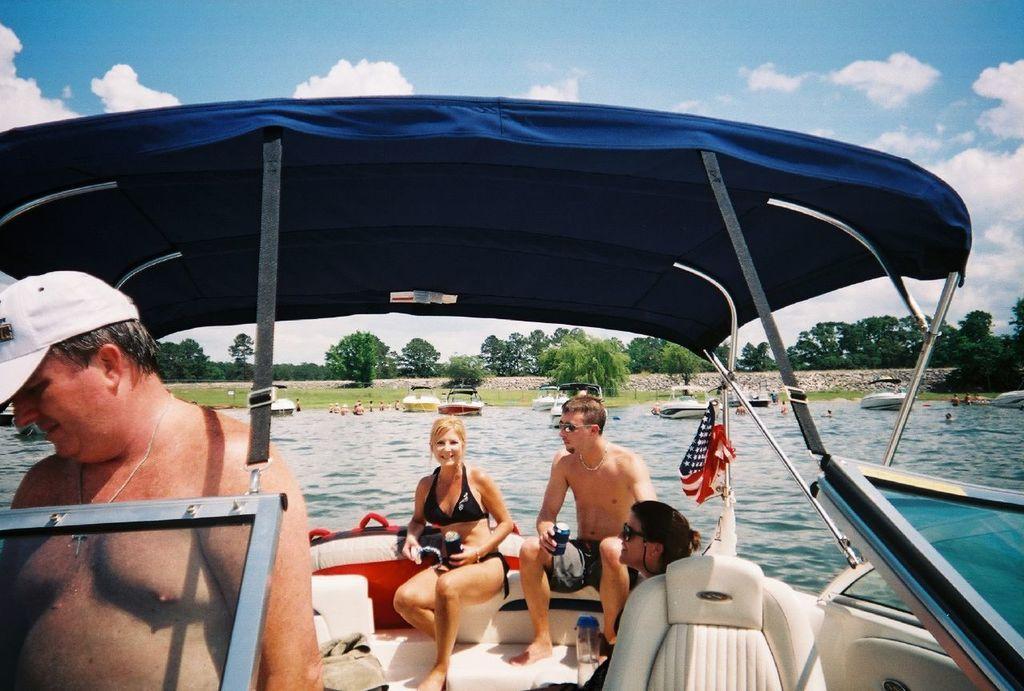In one or two sentences, can you explain what this image depicts? There are few people in a boat and we can see flag. We can see boats above the water and people. In the background we can see trees and sky with clouds. 